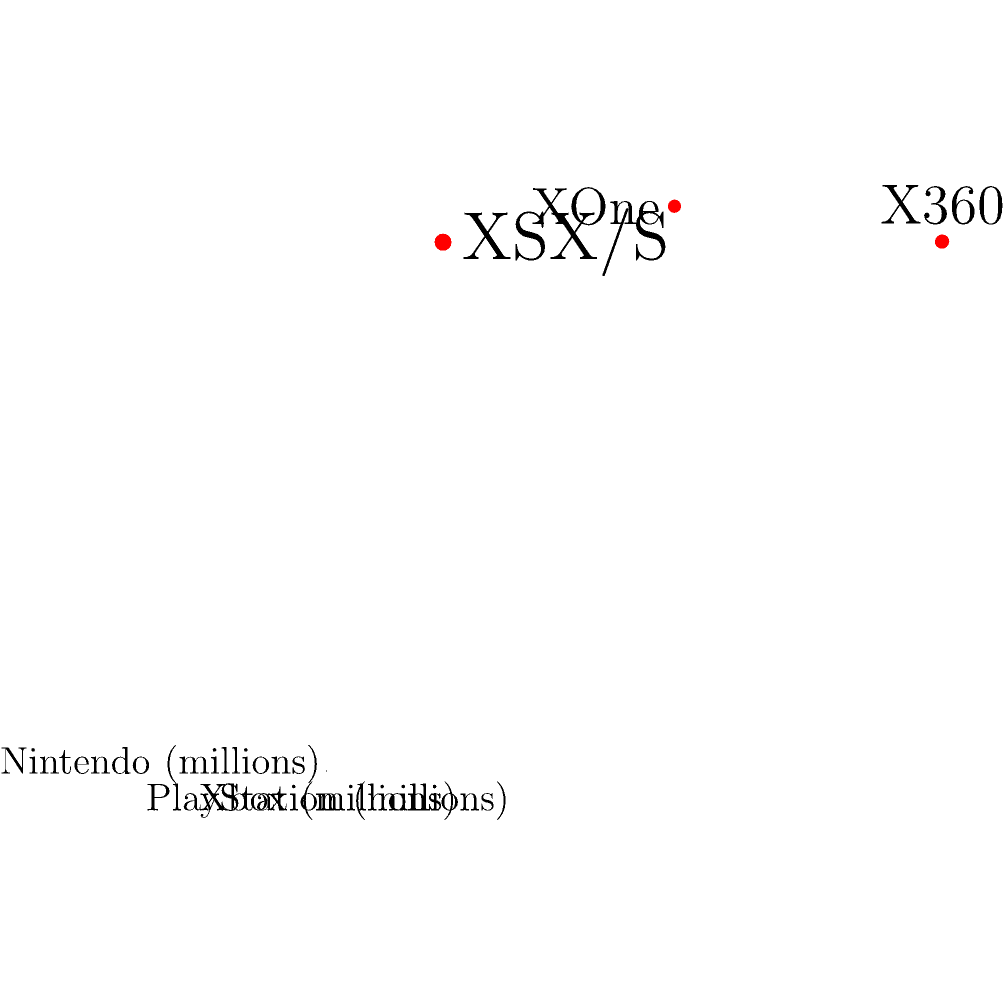In the 3D coordinate system shown, each axis represents sales figures (in millions) for a major gaming console brand: Xbox (x-axis), PlayStation (y-axis), and Nintendo (z-axis). Three data points are plotted, representing different console generations. Which console generation shows the highest combined sales across all three brands, and what is the total sales figure for that generation? To solve this problem, we need to follow these steps:

1. Identify the three console generations:
   - Point 1: Xbox 360, PS3, Wii
   - Point 2: Xbox One, PS4, Wii U
   - Point 3: Xbox Series X/S, PS5, Nintendo Switch

2. Calculate the total sales for each generation:
   - Generation 1: $24 + 155 + 101.63 = 280.63$ million
   - Generation 2: $24 + 106 + 101.64 = 231.64$ million
   - Generation 3: $85.8 + 117.2 + 111.08 = 314.08$ million

3. Compare the totals:
   Generation 3 has the highest combined sales at 314.08 million units.

4. Identify the console names for the highest-selling generation:
   Xbox Series X/S, PS5, and Nintendo Switch

Therefore, the latest console generation (Xbox Series X/S, PS5, and Nintendo Switch) shows the highest combined sales across all three brands, with a total of 314.08 million units sold.
Answer: Latest generation (Xbox Series X/S, PS5, Nintendo Switch); 314.08 million units 